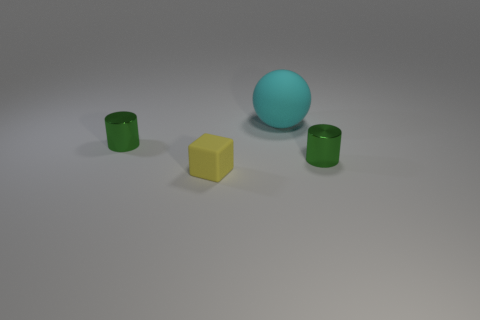Add 2 tiny matte objects. How many objects exist? 6 Subtract all cubes. How many objects are left? 3 Add 2 tiny cubes. How many tiny cubes exist? 3 Subtract 0 green spheres. How many objects are left? 4 Subtract all yellow metal balls. Subtract all large cyan matte things. How many objects are left? 3 Add 2 small green metallic things. How many small green metallic things are left? 4 